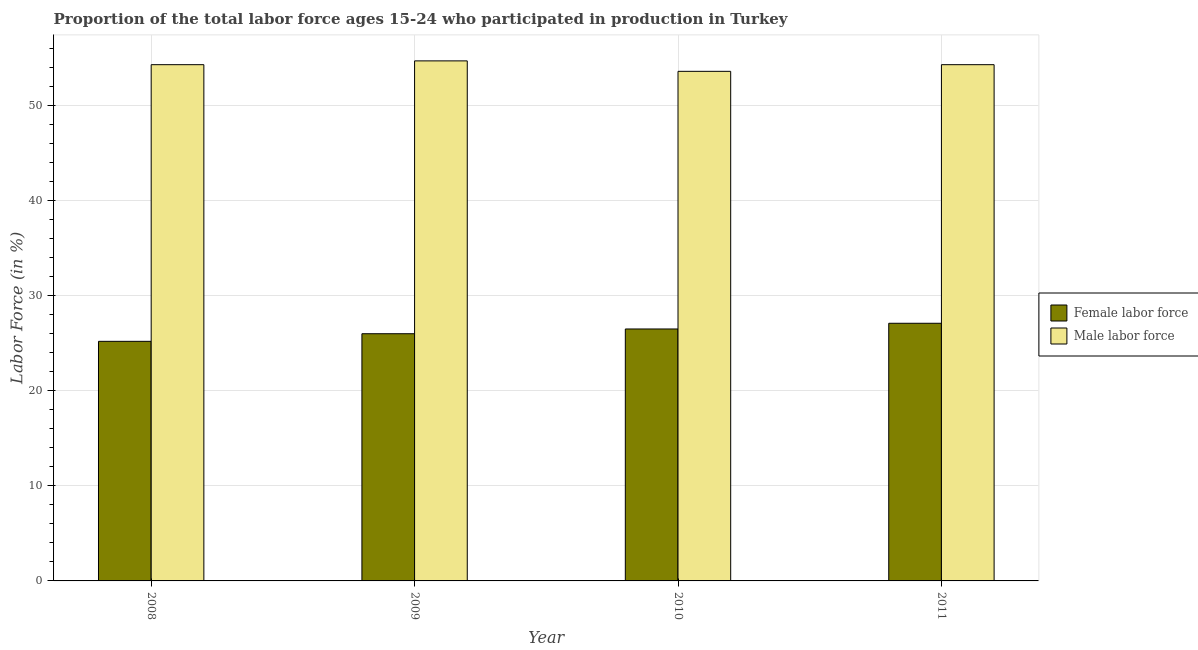Are the number of bars per tick equal to the number of legend labels?
Your answer should be very brief. Yes. Are the number of bars on each tick of the X-axis equal?
Your response must be concise. Yes. How many bars are there on the 3rd tick from the right?
Offer a very short reply. 2. What is the percentage of male labour force in 2010?
Give a very brief answer. 53.6. Across all years, what is the maximum percentage of male labour force?
Keep it short and to the point. 54.7. Across all years, what is the minimum percentage of male labour force?
Offer a terse response. 53.6. In which year was the percentage of female labor force maximum?
Offer a terse response. 2011. What is the total percentage of female labor force in the graph?
Provide a short and direct response. 104.8. What is the average percentage of male labour force per year?
Ensure brevity in your answer.  54.22. In the year 2010, what is the difference between the percentage of female labor force and percentage of male labour force?
Offer a very short reply. 0. In how many years, is the percentage of female labor force greater than 16 %?
Your answer should be very brief. 4. What is the ratio of the percentage of female labor force in 2008 to that in 2010?
Your response must be concise. 0.95. What is the difference between the highest and the second highest percentage of female labor force?
Give a very brief answer. 0.6. What is the difference between the highest and the lowest percentage of female labor force?
Offer a very short reply. 1.9. What does the 1st bar from the left in 2010 represents?
Your answer should be compact. Female labor force. What does the 1st bar from the right in 2010 represents?
Provide a short and direct response. Male labor force. Are all the bars in the graph horizontal?
Ensure brevity in your answer.  No. How many years are there in the graph?
Offer a terse response. 4. What is the difference between two consecutive major ticks on the Y-axis?
Offer a very short reply. 10. Are the values on the major ticks of Y-axis written in scientific E-notation?
Your answer should be compact. No. Does the graph contain any zero values?
Keep it short and to the point. No. Does the graph contain grids?
Your response must be concise. Yes. Where does the legend appear in the graph?
Offer a terse response. Center right. How are the legend labels stacked?
Your response must be concise. Vertical. What is the title of the graph?
Offer a terse response. Proportion of the total labor force ages 15-24 who participated in production in Turkey. Does "Stunting" appear as one of the legend labels in the graph?
Offer a terse response. No. What is the label or title of the X-axis?
Your answer should be compact. Year. What is the label or title of the Y-axis?
Ensure brevity in your answer.  Labor Force (in %). What is the Labor Force (in %) of Female labor force in 2008?
Provide a short and direct response. 25.2. What is the Labor Force (in %) of Male labor force in 2008?
Offer a very short reply. 54.3. What is the Labor Force (in %) of Male labor force in 2009?
Offer a terse response. 54.7. What is the Labor Force (in %) of Female labor force in 2010?
Make the answer very short. 26.5. What is the Labor Force (in %) of Male labor force in 2010?
Keep it short and to the point. 53.6. What is the Labor Force (in %) of Female labor force in 2011?
Give a very brief answer. 27.1. What is the Labor Force (in %) of Male labor force in 2011?
Provide a short and direct response. 54.3. Across all years, what is the maximum Labor Force (in %) of Female labor force?
Your response must be concise. 27.1. Across all years, what is the maximum Labor Force (in %) of Male labor force?
Your answer should be very brief. 54.7. Across all years, what is the minimum Labor Force (in %) of Female labor force?
Give a very brief answer. 25.2. Across all years, what is the minimum Labor Force (in %) of Male labor force?
Your answer should be compact. 53.6. What is the total Labor Force (in %) in Female labor force in the graph?
Offer a terse response. 104.8. What is the total Labor Force (in %) of Male labor force in the graph?
Your response must be concise. 216.9. What is the difference between the Labor Force (in %) of Female labor force in 2008 and that in 2009?
Keep it short and to the point. -0.8. What is the difference between the Labor Force (in %) in Female labor force in 2008 and that in 2010?
Provide a short and direct response. -1.3. What is the difference between the Labor Force (in %) of Female labor force in 2008 and that in 2011?
Ensure brevity in your answer.  -1.9. What is the difference between the Labor Force (in %) in Male labor force in 2008 and that in 2011?
Keep it short and to the point. 0. What is the difference between the Labor Force (in %) of Male labor force in 2009 and that in 2010?
Provide a succinct answer. 1.1. What is the difference between the Labor Force (in %) in Female labor force in 2008 and the Labor Force (in %) in Male labor force in 2009?
Your answer should be very brief. -29.5. What is the difference between the Labor Force (in %) of Female labor force in 2008 and the Labor Force (in %) of Male labor force in 2010?
Provide a short and direct response. -28.4. What is the difference between the Labor Force (in %) in Female labor force in 2008 and the Labor Force (in %) in Male labor force in 2011?
Make the answer very short. -29.1. What is the difference between the Labor Force (in %) of Female labor force in 2009 and the Labor Force (in %) of Male labor force in 2010?
Ensure brevity in your answer.  -27.6. What is the difference between the Labor Force (in %) in Female labor force in 2009 and the Labor Force (in %) in Male labor force in 2011?
Provide a short and direct response. -28.3. What is the difference between the Labor Force (in %) of Female labor force in 2010 and the Labor Force (in %) of Male labor force in 2011?
Offer a terse response. -27.8. What is the average Labor Force (in %) of Female labor force per year?
Make the answer very short. 26.2. What is the average Labor Force (in %) of Male labor force per year?
Make the answer very short. 54.23. In the year 2008, what is the difference between the Labor Force (in %) of Female labor force and Labor Force (in %) of Male labor force?
Make the answer very short. -29.1. In the year 2009, what is the difference between the Labor Force (in %) in Female labor force and Labor Force (in %) in Male labor force?
Offer a terse response. -28.7. In the year 2010, what is the difference between the Labor Force (in %) of Female labor force and Labor Force (in %) of Male labor force?
Offer a very short reply. -27.1. In the year 2011, what is the difference between the Labor Force (in %) of Female labor force and Labor Force (in %) of Male labor force?
Provide a succinct answer. -27.2. What is the ratio of the Labor Force (in %) in Female labor force in 2008 to that in 2009?
Ensure brevity in your answer.  0.97. What is the ratio of the Labor Force (in %) in Male labor force in 2008 to that in 2009?
Give a very brief answer. 0.99. What is the ratio of the Labor Force (in %) of Female labor force in 2008 to that in 2010?
Make the answer very short. 0.95. What is the ratio of the Labor Force (in %) in Male labor force in 2008 to that in 2010?
Your answer should be very brief. 1.01. What is the ratio of the Labor Force (in %) in Female labor force in 2008 to that in 2011?
Your answer should be very brief. 0.93. What is the ratio of the Labor Force (in %) of Female labor force in 2009 to that in 2010?
Your response must be concise. 0.98. What is the ratio of the Labor Force (in %) of Male labor force in 2009 to that in 2010?
Offer a terse response. 1.02. What is the ratio of the Labor Force (in %) of Female labor force in 2009 to that in 2011?
Keep it short and to the point. 0.96. What is the ratio of the Labor Force (in %) of Male labor force in 2009 to that in 2011?
Provide a succinct answer. 1.01. What is the ratio of the Labor Force (in %) in Female labor force in 2010 to that in 2011?
Offer a very short reply. 0.98. What is the ratio of the Labor Force (in %) of Male labor force in 2010 to that in 2011?
Ensure brevity in your answer.  0.99. What is the difference between the highest and the second highest Labor Force (in %) of Female labor force?
Offer a very short reply. 0.6. What is the difference between the highest and the second highest Labor Force (in %) of Male labor force?
Your answer should be very brief. 0.4. What is the difference between the highest and the lowest Labor Force (in %) in Female labor force?
Your response must be concise. 1.9. 